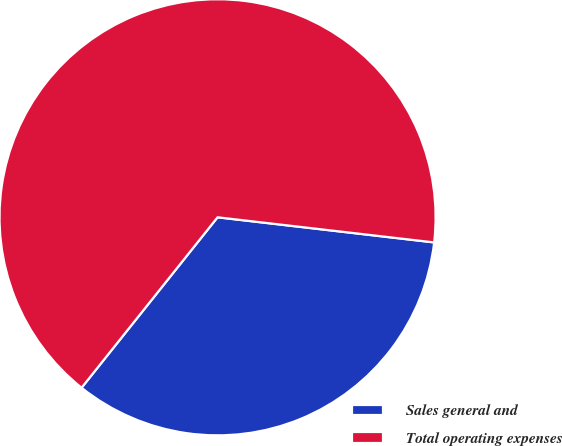Convert chart. <chart><loc_0><loc_0><loc_500><loc_500><pie_chart><fcel>Sales general and<fcel>Total operating expenses<nl><fcel>33.88%<fcel>66.12%<nl></chart> 